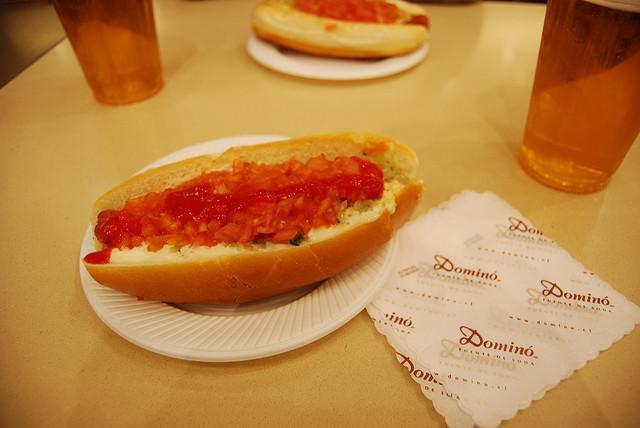How many hot dogs are there?
Give a very brief answer. 2. How many cups are there?
Give a very brief answer. 2. How many birds are here?
Give a very brief answer. 0. 